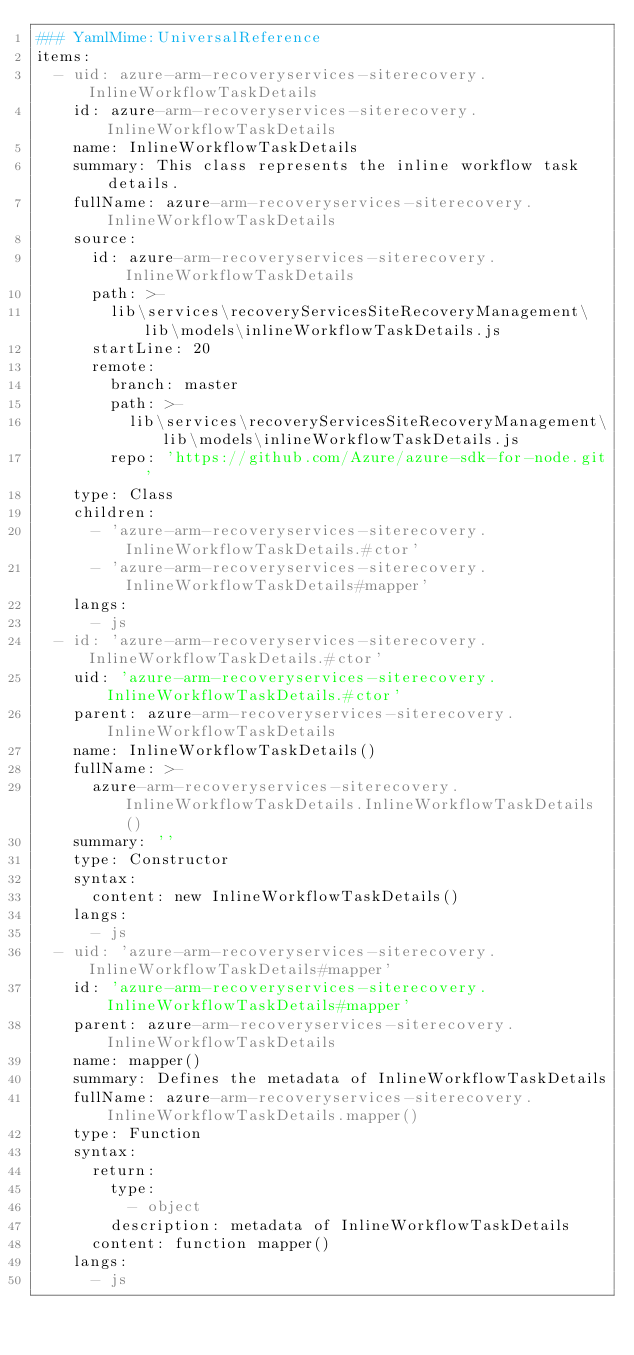<code> <loc_0><loc_0><loc_500><loc_500><_YAML_>### YamlMime:UniversalReference
items:
  - uid: azure-arm-recoveryservices-siterecovery.InlineWorkflowTaskDetails
    id: azure-arm-recoveryservices-siterecovery.InlineWorkflowTaskDetails
    name: InlineWorkflowTaskDetails
    summary: This class represents the inline workflow task details.
    fullName: azure-arm-recoveryservices-siterecovery.InlineWorkflowTaskDetails
    source:
      id: azure-arm-recoveryservices-siterecovery.InlineWorkflowTaskDetails
      path: >-
        lib\services\recoveryServicesSiteRecoveryManagement\lib\models\inlineWorkflowTaskDetails.js
      startLine: 20
      remote:
        branch: master
        path: >-
          lib\services\recoveryServicesSiteRecoveryManagement\lib\models\inlineWorkflowTaskDetails.js
        repo: 'https://github.com/Azure/azure-sdk-for-node.git'
    type: Class
    children:
      - 'azure-arm-recoveryservices-siterecovery.InlineWorkflowTaskDetails.#ctor'
      - 'azure-arm-recoveryservices-siterecovery.InlineWorkflowTaskDetails#mapper'
    langs:
      - js
  - id: 'azure-arm-recoveryservices-siterecovery.InlineWorkflowTaskDetails.#ctor'
    uid: 'azure-arm-recoveryservices-siterecovery.InlineWorkflowTaskDetails.#ctor'
    parent: azure-arm-recoveryservices-siterecovery.InlineWorkflowTaskDetails
    name: InlineWorkflowTaskDetails()
    fullName: >-
      azure-arm-recoveryservices-siterecovery.InlineWorkflowTaskDetails.InlineWorkflowTaskDetails()
    summary: ''
    type: Constructor
    syntax:
      content: new InlineWorkflowTaskDetails()
    langs:
      - js
  - uid: 'azure-arm-recoveryservices-siterecovery.InlineWorkflowTaskDetails#mapper'
    id: 'azure-arm-recoveryservices-siterecovery.InlineWorkflowTaskDetails#mapper'
    parent: azure-arm-recoveryservices-siterecovery.InlineWorkflowTaskDetails
    name: mapper()
    summary: Defines the metadata of InlineWorkflowTaskDetails
    fullName: azure-arm-recoveryservices-siterecovery.InlineWorkflowTaskDetails.mapper()
    type: Function
    syntax:
      return:
        type:
          - object
        description: metadata of InlineWorkflowTaskDetails
      content: function mapper()
    langs:
      - js
</code> 